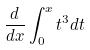Convert formula to latex. <formula><loc_0><loc_0><loc_500><loc_500>\frac { d } { d x } \int _ { 0 } ^ { x } t ^ { 3 } d t</formula> 